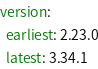Convert code to text. <code><loc_0><loc_0><loc_500><loc_500><_YAML_>version:
  earliest: 2.23.0
  latest: 3.34.1
</code> 